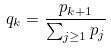<formula> <loc_0><loc_0><loc_500><loc_500>q _ { k } = \frac { p _ { k + 1 } } { \sum _ { j \geq 1 } p _ { j } }</formula> 